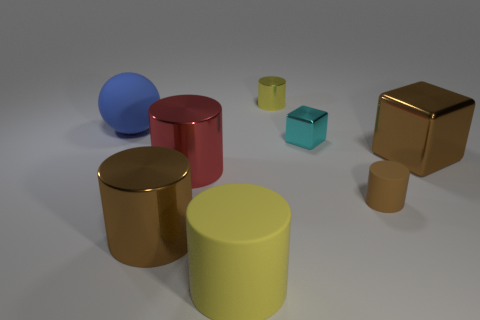Subtract all big red cylinders. How many cylinders are left? 4 Add 2 small green metallic spheres. How many objects exist? 10 Subtract all yellow spheres. How many brown cylinders are left? 2 Subtract all red cylinders. How many cylinders are left? 4 Subtract all spheres. How many objects are left? 7 Subtract 0 purple cubes. How many objects are left? 8 Subtract all purple blocks. Subtract all blue cylinders. How many blocks are left? 2 Subtract all big yellow things. Subtract all rubber cylinders. How many objects are left? 5 Add 1 brown metal cylinders. How many brown metal cylinders are left? 2 Add 8 small brown rubber objects. How many small brown rubber objects exist? 9 